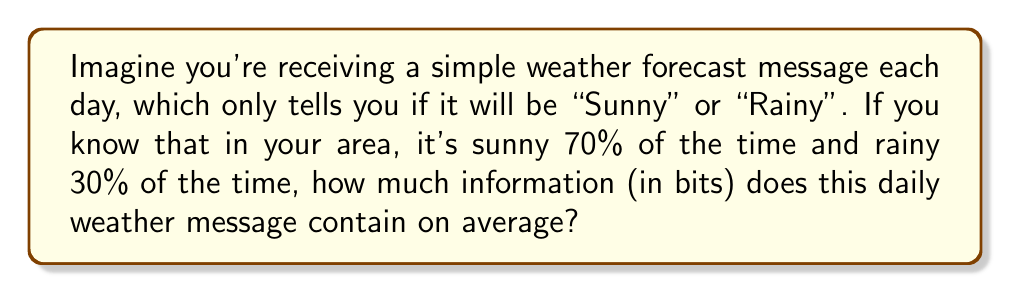Show me your answer to this math problem. Let's break this down step-by-step using Shannon's entropy formula:

1) Shannon's entropy formula is:

   $$ H = -\sum_{i=1}^{n} p_i \log_2(p_i) $$

   Where $H$ is the entropy (average information content), $p_i$ is the probability of each possible message, and $n$ is the number of possible messages.

2) In this case, we have two possible messages:
   - Sunny (probability = 0.7)
   - Rainy (probability = 0.3)

3) Let's plug these into the formula:

   $$ H = -(0.7 \log_2(0.7) + 0.3 \log_2(0.3)) $$

4) Now, let's calculate each part:
   
   $0.7 \log_2(0.7) \approx -0.3601$
   $0.3 \log_2(0.3) \approx -0.5211$

5) Adding these together:

   $$ H = -(-0.3601 - 0.5211) = 0.8812 $$

6) Therefore, the average information content of each message is approximately 0.8812 bits.

This means that even though the message only has two possible outcomes, it doesn't contain a full bit of information on average. This is because the outcomes are not equally likely - sunny days are more common, making them less informative when they occur.
Answer: The daily weather message contains approximately 0.8812 bits of information on average. 